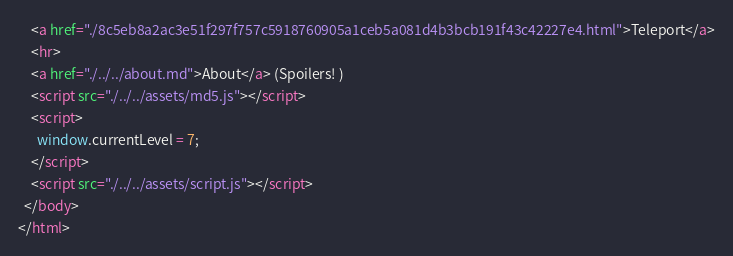<code> <loc_0><loc_0><loc_500><loc_500><_HTML_>    <a href="./8c5eb8a2ac3e51f297f757c5918760905a1ceb5a081d4b3bcb191f43c42227e4.html">Teleport</a>
    <hr>
    <a href="./../../about.md">About</a> (Spoilers! )
    <script src="./../../assets/md5.js"></script>
    <script>
      window.currentLevel = 7;
    </script>
    <script src="./../../assets/script.js"></script>
  </body>
</html></code> 